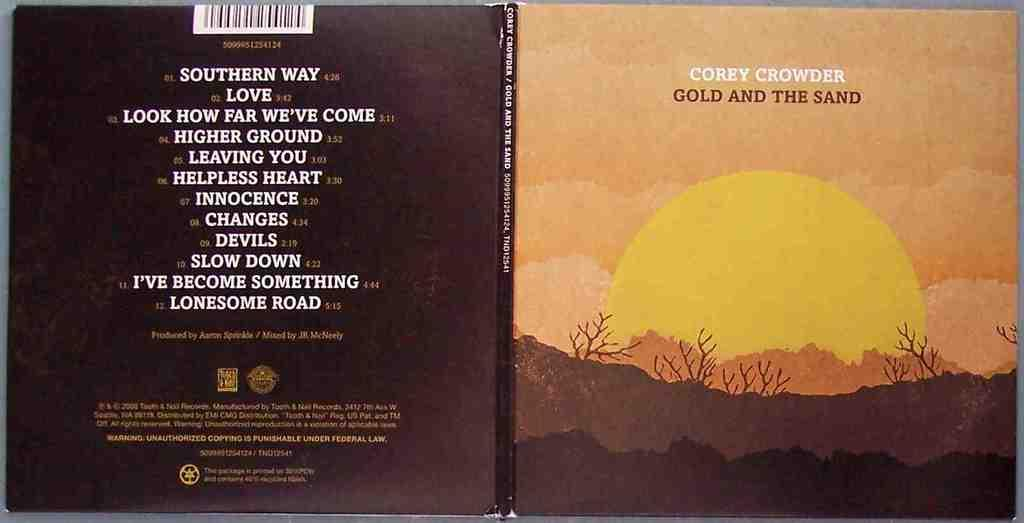What object is present in the image that contains written information? There is a book in the image that has text on it. Are there any visual elements on the book? Yes, the book has images on it. Can you describe the content of the book based on the image? Based on the image, we can see that the book has both text and images, but we cannot determine the specific content. What type of ship can be seen sailing through the sleet in the image? There is no ship or sleet present in the image; it features a book with text and images. How does the daughter interact with the book in the image? There is no daughter present in the image; it only features a book with text and images. 